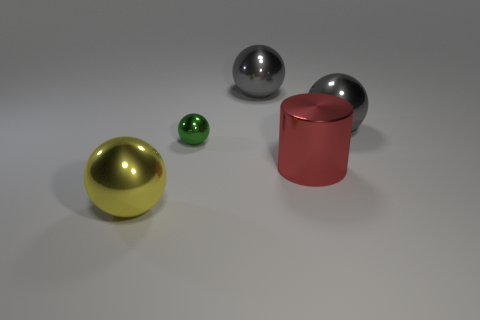What's the relative size of the objects compared to one another? The objects display noticeable variations in size. The large gold ball is the biggest object, followed by the medium-sized silver ball which is slightly smaller. The red cylindrical object, while not as wide, is taller than the silver ball but shorter than the gold one. Lastly, the small green ball is significantly smaller than all the other objects. 